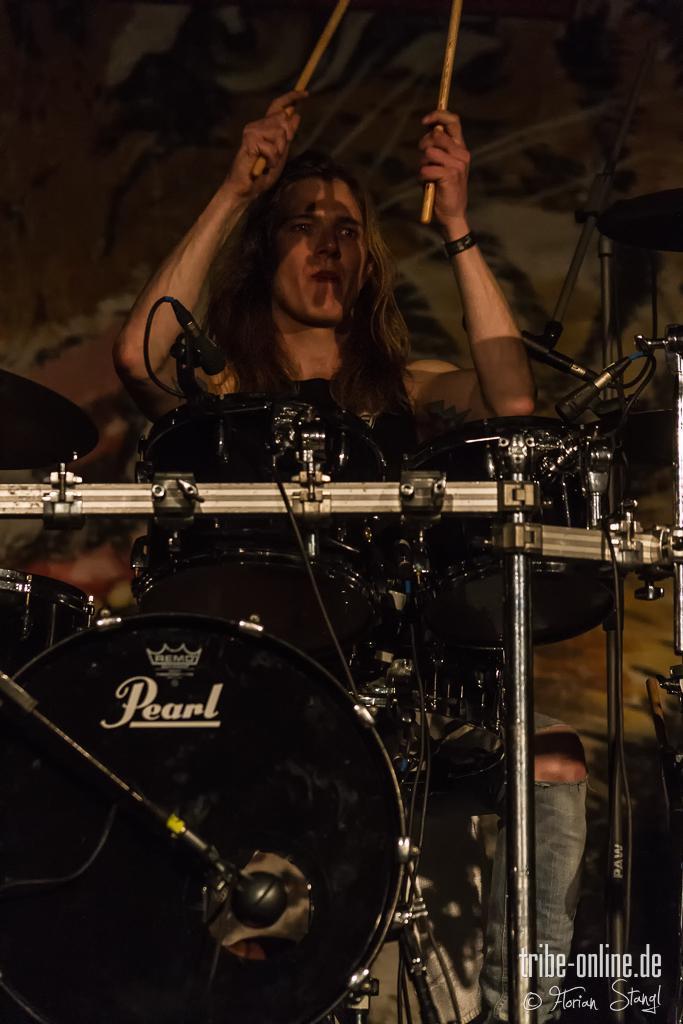In one or two sentences, can you explain what this image depicts? In the picture I can see a woman in the middle of the image and she is holding the drumsticks in her hands. I can see the snare drum musical instrument. 